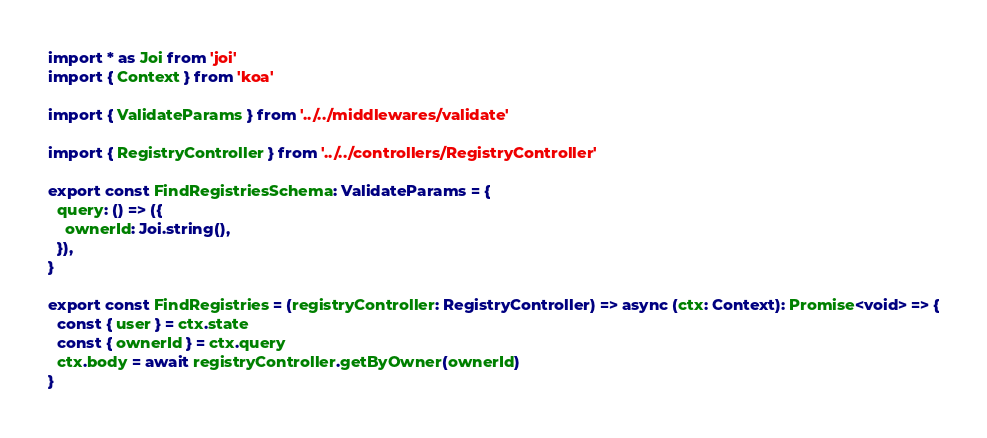Convert code to text. <code><loc_0><loc_0><loc_500><loc_500><_TypeScript_>import * as Joi from 'joi'
import { Context } from 'koa'

import { ValidateParams } from '../../middlewares/validate'

import { RegistryController } from '../../controllers/RegistryController'

export const FindRegistriesSchema: ValidateParams = {
  query: () => ({
    ownerId: Joi.string(),
  }),
}

export const FindRegistries = (registryController: RegistryController) => async (ctx: Context): Promise<void> => {
  const { user } = ctx.state
  const { ownerId } = ctx.query
  ctx.body = await registryController.getByOwner(ownerId)
}
</code> 